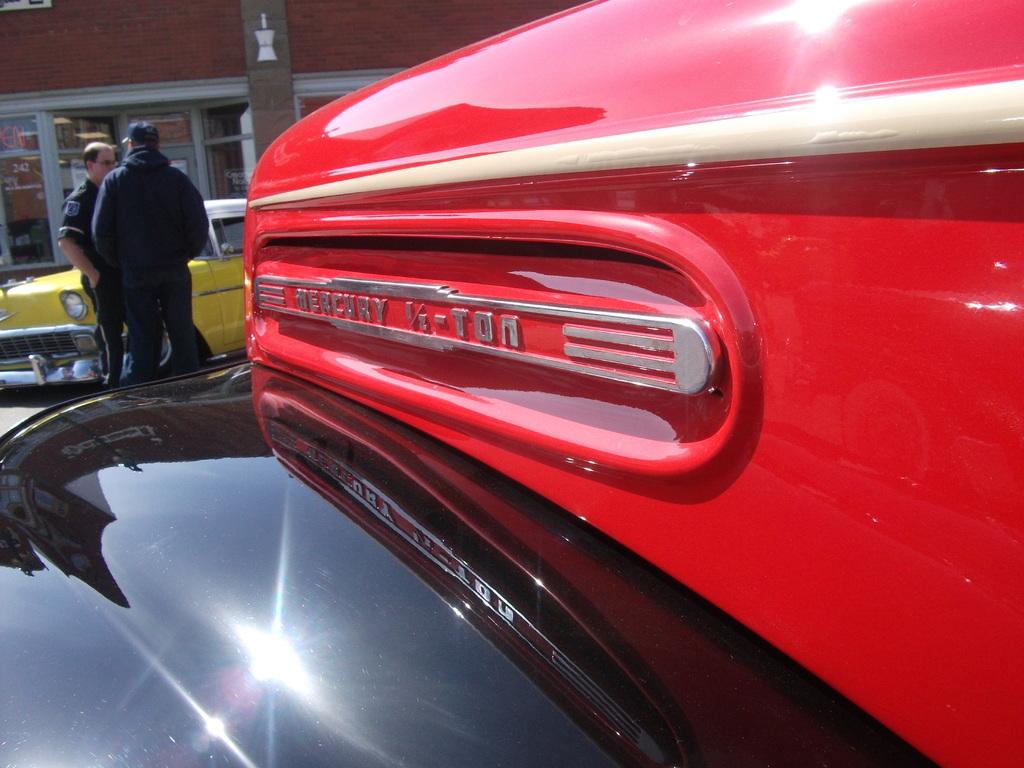What type of vehicle is this?
Your answer should be very brief. Mercury. Who is the manufacturer of this vehicle?
Make the answer very short. Mercury. 